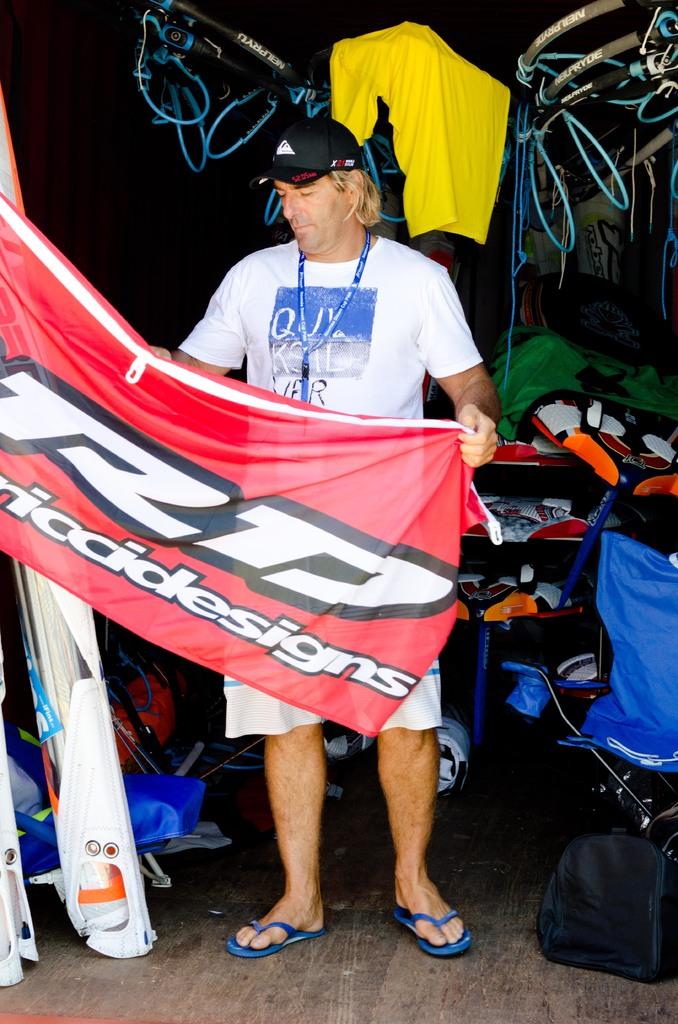What sort of business does this man own?
Offer a terse response. Design. What two letters are on the top of the red banner?
Give a very brief answer. Rd. 